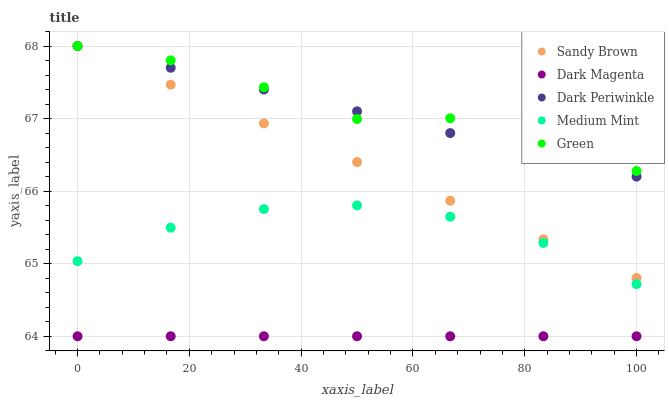Does Dark Magenta have the minimum area under the curve?
Answer yes or no. Yes. Does Green have the maximum area under the curve?
Answer yes or no. Yes. Does Sandy Brown have the minimum area under the curve?
Answer yes or no. No. Does Sandy Brown have the maximum area under the curve?
Answer yes or no. No. Is Dark Magenta the smoothest?
Answer yes or no. Yes. Is Green the roughest?
Answer yes or no. Yes. Is Sandy Brown the smoothest?
Answer yes or no. No. Is Sandy Brown the roughest?
Answer yes or no. No. Does Dark Magenta have the lowest value?
Answer yes or no. Yes. Does Sandy Brown have the lowest value?
Answer yes or no. No. Does Dark Periwinkle have the highest value?
Answer yes or no. Yes. Does Dark Magenta have the highest value?
Answer yes or no. No. Is Medium Mint less than Dark Periwinkle?
Answer yes or no. Yes. Is Green greater than Dark Magenta?
Answer yes or no. Yes. Does Green intersect Dark Periwinkle?
Answer yes or no. Yes. Is Green less than Dark Periwinkle?
Answer yes or no. No. Is Green greater than Dark Periwinkle?
Answer yes or no. No. Does Medium Mint intersect Dark Periwinkle?
Answer yes or no. No. 